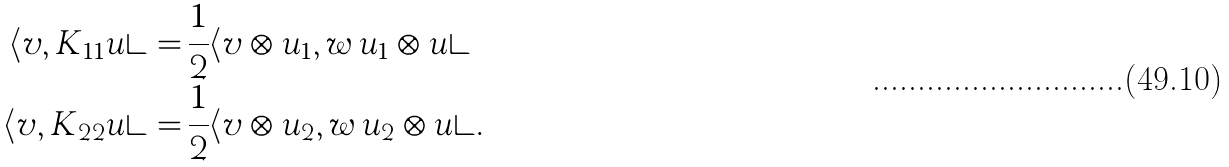Convert formula to latex. <formula><loc_0><loc_0><loc_500><loc_500>\langle v , K _ { 1 1 } u \rangle = \, & \frac { 1 } { 2 } \langle v \otimes u _ { 1 } , w \, u _ { 1 } \otimes u \rangle \\ \langle v , K _ { 2 2 } u \rangle = \, & \frac { 1 } { 2 } \langle v \otimes u _ { 2 } , w \, u _ { 2 } \otimes u \rangle .</formula> 